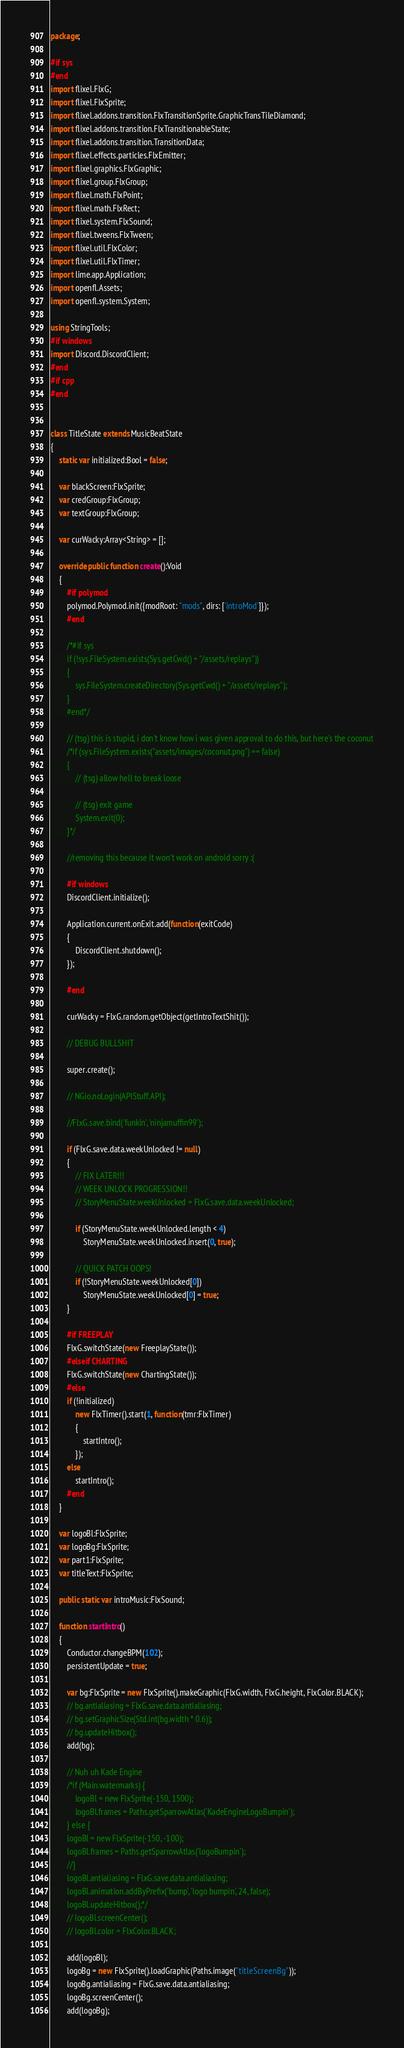<code> <loc_0><loc_0><loc_500><loc_500><_Haxe_>package;

#if sys
#end
import flixel.FlxG;
import flixel.FlxSprite;
import flixel.addons.transition.FlxTransitionSprite.GraphicTransTileDiamond;
import flixel.addons.transition.FlxTransitionableState;
import flixel.addons.transition.TransitionData;
import flixel.effects.particles.FlxEmitter;
import flixel.graphics.FlxGraphic;
import flixel.group.FlxGroup;
import flixel.math.FlxPoint;
import flixel.math.FlxRect;
import flixel.system.FlxSound;
import flixel.tweens.FlxTween;
import flixel.util.FlxColor;
import flixel.util.FlxTimer;
import lime.app.Application;
import openfl.Assets;
import openfl.system.System;

using StringTools;
#if windows
import Discord.DiscordClient;
#end
#if cpp
#end


class TitleState extends MusicBeatState
{
	static var initialized:Bool = false;

	var blackScreen:FlxSprite;
	var credGroup:FlxGroup;
	var textGroup:FlxGroup;

	var curWacky:Array<String> = [];

	override public function create():Void
	{
		#if polymod
		polymod.Polymod.init({modRoot: "mods", dirs: ['introMod']});
		#end

		/*#if sys
		if (!sys.FileSystem.exists(Sys.getCwd() + "/assets/replays"))
		{
			sys.FileSystem.createDirectory(Sys.getCwd() + "/assets/replays");
		}
		#end*/

		// (tsg) this is stupid, i don't know how i was given approval to do this, but here's the coconut
		/*if (sys.FileSystem.exists("assets/images/coconut.png") == false)
		{
			// (tsg) allow hell to break loose

			// (tsg) exit game
			System.exit(0);
		}*/

		//removing this because it won't work on android sorry :(

		#if windows
		DiscordClient.initialize();

		Application.current.onExit.add(function(exitCode)
		{
			DiscordClient.shutdown();
		});

		#end

		curWacky = FlxG.random.getObject(getIntroTextShit());

		// DEBUG BULLSHIT

		super.create();

		// NGio.noLogin(APIStuff.API);

		//FlxG.save.bind('funkin', 'ninjamuffin99');

		if (FlxG.save.data.weekUnlocked != null)
		{
			// FIX LATER!!!
			// WEEK UNLOCK PROGRESSION!!
			// StoryMenuState.weekUnlocked = FlxG.save.data.weekUnlocked;

			if (StoryMenuState.weekUnlocked.length < 4)
				StoryMenuState.weekUnlocked.insert(0, true);

			// QUICK PATCH OOPS!
			if (!StoryMenuState.weekUnlocked[0])
				StoryMenuState.weekUnlocked[0] = true;
		}

		#if FREEPLAY
		FlxG.switchState(new FreeplayState());
		#elseif CHARTING
		FlxG.switchState(new ChartingState());
		#else
		if (!initialized)
			new FlxTimer().start(1, function(tmr:FlxTimer)
			{
				startIntro();
			});
		else
			startIntro();
		#end
	}

	var logoBl:FlxSprite;
	var logoBg:FlxSprite;
	var part1:FlxSprite;
	var titleText:FlxSprite;

	public static var introMusic:FlxSound;

	function startIntro()
	{
		Conductor.changeBPM(102);
		persistentUpdate = true;

		var bg:FlxSprite = new FlxSprite().makeGraphic(FlxG.width, FlxG.height, FlxColor.BLACK);
		// bg.antialiasing = FlxG.save.data.antialiasing;
		// bg.setGraphicSize(Std.int(bg.width * 0.6));
		// bg.updateHitbox();
		add(bg);

		// Nuh uh Kade Engine
		/*if (Main.watermarks) {
			logoBl = new FlxSprite(-150, 1500);
			logoBl.frames = Paths.getSparrowAtlas('KadeEngineLogoBumpin');
		} else {
		logoBl = new FlxSprite(-150, -100);
		logoBl.frames = Paths.getSparrowAtlas('logoBumpin');
		//}
		logoBl.antialiasing = FlxG.save.data.antialiasing;
		logoBl.animation.addByPrefix('bump', 'logo bumpin', 24, false);
		logoBl.updateHitbox();*/
		// logoBl.screenCenter();
		// logoBl.color = FlxColor.BLACK;

		add(logoBl);
		logoBg = new FlxSprite().loadGraphic(Paths.image("titleScreenBg"));
		logoBg.antialiasing = FlxG.save.data.antialiasing;
		logoBg.screenCenter();
		add(logoBg);
</code> 